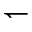Convert formula to latex. <formula><loc_0><loc_0><loc_500><loc_500>\leftharpoondown</formula> 